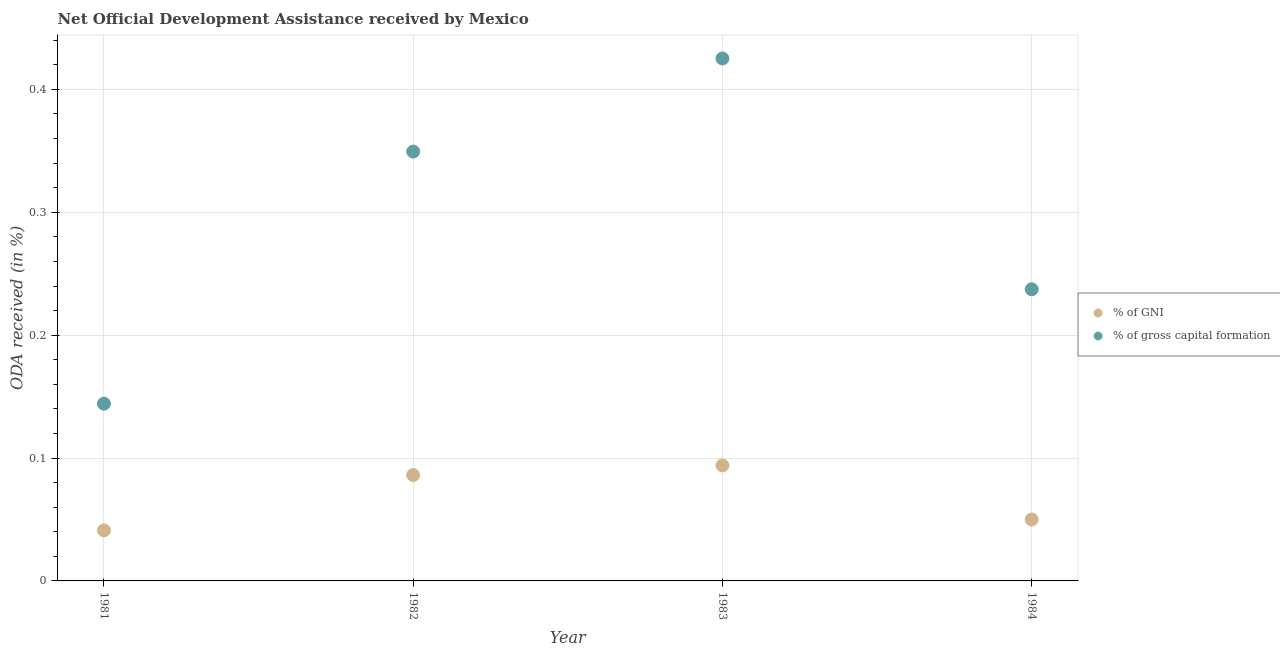What is the oda received as percentage of gni in 1984?
Keep it short and to the point. 0.05. Across all years, what is the maximum oda received as percentage of gni?
Your answer should be compact. 0.09. Across all years, what is the minimum oda received as percentage of gross capital formation?
Provide a succinct answer. 0.14. In which year was the oda received as percentage of gross capital formation minimum?
Your response must be concise. 1981. What is the total oda received as percentage of gni in the graph?
Keep it short and to the point. 0.27. What is the difference between the oda received as percentage of gross capital formation in 1981 and that in 1983?
Your answer should be compact. -0.28. What is the difference between the oda received as percentage of gross capital formation in 1982 and the oda received as percentage of gni in 1981?
Keep it short and to the point. 0.31. What is the average oda received as percentage of gni per year?
Give a very brief answer. 0.07. In the year 1981, what is the difference between the oda received as percentage of gross capital formation and oda received as percentage of gni?
Offer a terse response. 0.1. In how many years, is the oda received as percentage of gni greater than 0.30000000000000004 %?
Keep it short and to the point. 0. What is the ratio of the oda received as percentage of gross capital formation in 1982 to that in 1983?
Provide a succinct answer. 0.82. Is the difference between the oda received as percentage of gross capital formation in 1981 and 1984 greater than the difference between the oda received as percentage of gni in 1981 and 1984?
Provide a succinct answer. No. What is the difference between the highest and the second highest oda received as percentage of gni?
Your answer should be very brief. 0.01. What is the difference between the highest and the lowest oda received as percentage of gni?
Your answer should be very brief. 0.05. In how many years, is the oda received as percentage of gross capital formation greater than the average oda received as percentage of gross capital formation taken over all years?
Your response must be concise. 2. Is the sum of the oda received as percentage of gross capital formation in 1982 and 1983 greater than the maximum oda received as percentage of gni across all years?
Provide a short and direct response. Yes. Does the oda received as percentage of gross capital formation monotonically increase over the years?
Ensure brevity in your answer.  No. Is the oda received as percentage of gross capital formation strictly greater than the oda received as percentage of gni over the years?
Keep it short and to the point. Yes. Is the oda received as percentage of gni strictly less than the oda received as percentage of gross capital formation over the years?
Your response must be concise. Yes. How many dotlines are there?
Provide a succinct answer. 2. Does the graph contain grids?
Offer a terse response. Yes. Where does the legend appear in the graph?
Provide a succinct answer. Center right. How many legend labels are there?
Offer a very short reply. 2. What is the title of the graph?
Your answer should be very brief. Net Official Development Assistance received by Mexico. Does "Frequency of shipment arrival" appear as one of the legend labels in the graph?
Provide a short and direct response. No. What is the label or title of the Y-axis?
Ensure brevity in your answer.  ODA received (in %). What is the ODA received (in %) of % of GNI in 1981?
Your answer should be compact. 0.04. What is the ODA received (in %) of % of gross capital formation in 1981?
Your answer should be compact. 0.14. What is the ODA received (in %) in % of GNI in 1982?
Your response must be concise. 0.09. What is the ODA received (in %) of % of gross capital formation in 1982?
Your answer should be very brief. 0.35. What is the ODA received (in %) in % of GNI in 1983?
Offer a very short reply. 0.09. What is the ODA received (in %) in % of gross capital formation in 1983?
Your answer should be very brief. 0.43. What is the ODA received (in %) of % of GNI in 1984?
Your response must be concise. 0.05. What is the ODA received (in %) of % of gross capital formation in 1984?
Keep it short and to the point. 0.24. Across all years, what is the maximum ODA received (in %) of % of GNI?
Make the answer very short. 0.09. Across all years, what is the maximum ODA received (in %) in % of gross capital formation?
Your answer should be very brief. 0.43. Across all years, what is the minimum ODA received (in %) of % of GNI?
Provide a short and direct response. 0.04. Across all years, what is the minimum ODA received (in %) of % of gross capital formation?
Your answer should be very brief. 0.14. What is the total ODA received (in %) of % of GNI in the graph?
Provide a succinct answer. 0.27. What is the total ODA received (in %) in % of gross capital formation in the graph?
Provide a succinct answer. 1.16. What is the difference between the ODA received (in %) of % of GNI in 1981 and that in 1982?
Ensure brevity in your answer.  -0.04. What is the difference between the ODA received (in %) of % of gross capital formation in 1981 and that in 1982?
Make the answer very short. -0.21. What is the difference between the ODA received (in %) in % of GNI in 1981 and that in 1983?
Offer a very short reply. -0.05. What is the difference between the ODA received (in %) of % of gross capital formation in 1981 and that in 1983?
Your answer should be compact. -0.28. What is the difference between the ODA received (in %) of % of GNI in 1981 and that in 1984?
Your answer should be very brief. -0.01. What is the difference between the ODA received (in %) of % of gross capital formation in 1981 and that in 1984?
Provide a succinct answer. -0.09. What is the difference between the ODA received (in %) of % of GNI in 1982 and that in 1983?
Give a very brief answer. -0.01. What is the difference between the ODA received (in %) in % of gross capital formation in 1982 and that in 1983?
Your answer should be very brief. -0.08. What is the difference between the ODA received (in %) in % of GNI in 1982 and that in 1984?
Provide a short and direct response. 0.04. What is the difference between the ODA received (in %) of % of gross capital formation in 1982 and that in 1984?
Keep it short and to the point. 0.11. What is the difference between the ODA received (in %) of % of GNI in 1983 and that in 1984?
Ensure brevity in your answer.  0.04. What is the difference between the ODA received (in %) of % of gross capital formation in 1983 and that in 1984?
Keep it short and to the point. 0.19. What is the difference between the ODA received (in %) of % of GNI in 1981 and the ODA received (in %) of % of gross capital formation in 1982?
Offer a terse response. -0.31. What is the difference between the ODA received (in %) in % of GNI in 1981 and the ODA received (in %) in % of gross capital formation in 1983?
Ensure brevity in your answer.  -0.38. What is the difference between the ODA received (in %) of % of GNI in 1981 and the ODA received (in %) of % of gross capital formation in 1984?
Make the answer very short. -0.2. What is the difference between the ODA received (in %) in % of GNI in 1982 and the ODA received (in %) in % of gross capital formation in 1983?
Ensure brevity in your answer.  -0.34. What is the difference between the ODA received (in %) in % of GNI in 1982 and the ODA received (in %) in % of gross capital formation in 1984?
Provide a succinct answer. -0.15. What is the difference between the ODA received (in %) in % of GNI in 1983 and the ODA received (in %) in % of gross capital formation in 1984?
Your response must be concise. -0.14. What is the average ODA received (in %) of % of GNI per year?
Keep it short and to the point. 0.07. What is the average ODA received (in %) of % of gross capital formation per year?
Give a very brief answer. 0.29. In the year 1981, what is the difference between the ODA received (in %) in % of GNI and ODA received (in %) in % of gross capital formation?
Make the answer very short. -0.1. In the year 1982, what is the difference between the ODA received (in %) of % of GNI and ODA received (in %) of % of gross capital formation?
Your answer should be compact. -0.26. In the year 1983, what is the difference between the ODA received (in %) of % of GNI and ODA received (in %) of % of gross capital formation?
Provide a succinct answer. -0.33. In the year 1984, what is the difference between the ODA received (in %) of % of GNI and ODA received (in %) of % of gross capital formation?
Give a very brief answer. -0.19. What is the ratio of the ODA received (in %) of % of GNI in 1981 to that in 1982?
Your response must be concise. 0.48. What is the ratio of the ODA received (in %) in % of gross capital formation in 1981 to that in 1982?
Make the answer very short. 0.41. What is the ratio of the ODA received (in %) of % of GNI in 1981 to that in 1983?
Your response must be concise. 0.44. What is the ratio of the ODA received (in %) in % of gross capital formation in 1981 to that in 1983?
Your answer should be very brief. 0.34. What is the ratio of the ODA received (in %) of % of GNI in 1981 to that in 1984?
Your answer should be compact. 0.82. What is the ratio of the ODA received (in %) of % of gross capital formation in 1981 to that in 1984?
Ensure brevity in your answer.  0.61. What is the ratio of the ODA received (in %) in % of GNI in 1982 to that in 1983?
Provide a short and direct response. 0.92. What is the ratio of the ODA received (in %) in % of gross capital formation in 1982 to that in 1983?
Offer a terse response. 0.82. What is the ratio of the ODA received (in %) in % of GNI in 1982 to that in 1984?
Your answer should be very brief. 1.72. What is the ratio of the ODA received (in %) of % of gross capital formation in 1982 to that in 1984?
Give a very brief answer. 1.47. What is the ratio of the ODA received (in %) of % of GNI in 1983 to that in 1984?
Your answer should be very brief. 1.88. What is the ratio of the ODA received (in %) in % of gross capital formation in 1983 to that in 1984?
Keep it short and to the point. 1.79. What is the difference between the highest and the second highest ODA received (in %) in % of GNI?
Keep it short and to the point. 0.01. What is the difference between the highest and the second highest ODA received (in %) in % of gross capital formation?
Provide a succinct answer. 0.08. What is the difference between the highest and the lowest ODA received (in %) of % of GNI?
Keep it short and to the point. 0.05. What is the difference between the highest and the lowest ODA received (in %) in % of gross capital formation?
Make the answer very short. 0.28. 